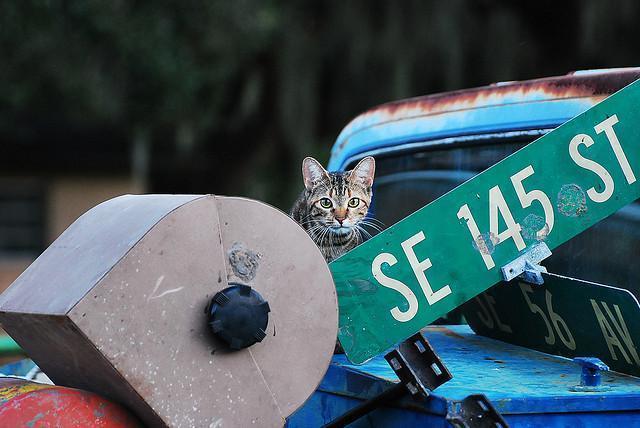How many cats are there?
Give a very brief answer. 1. 